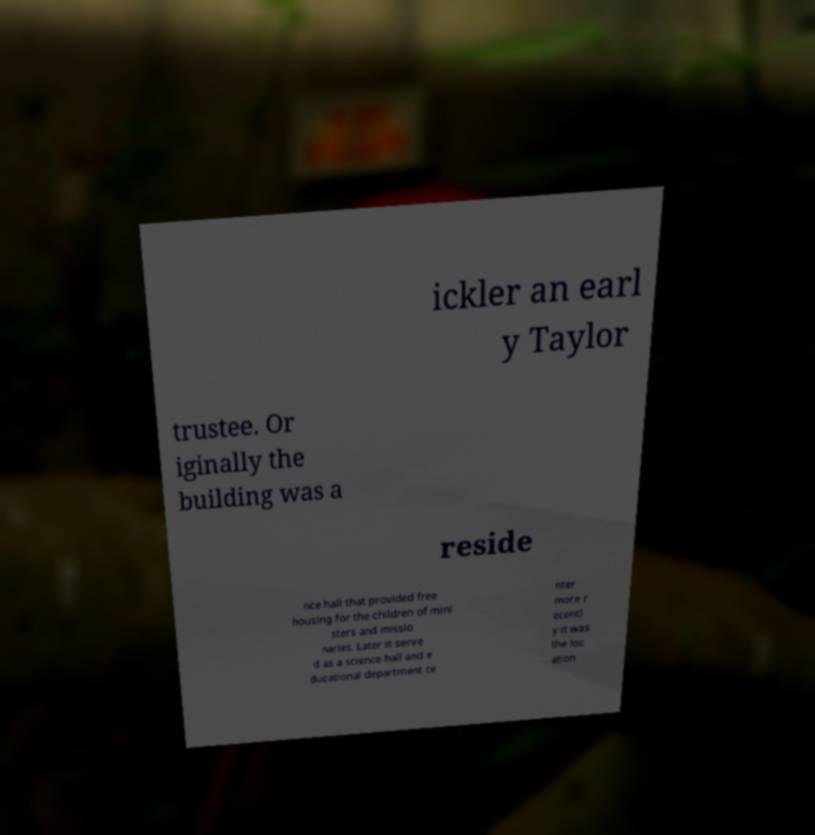Could you extract and type out the text from this image? ickler an earl y Taylor trustee. Or iginally the building was a reside nce hall that provided free housing for the children of mini sters and missio naries. Later it serve d as a science hall and e ducational department ce nter more r ecentl y it was the loc ation 